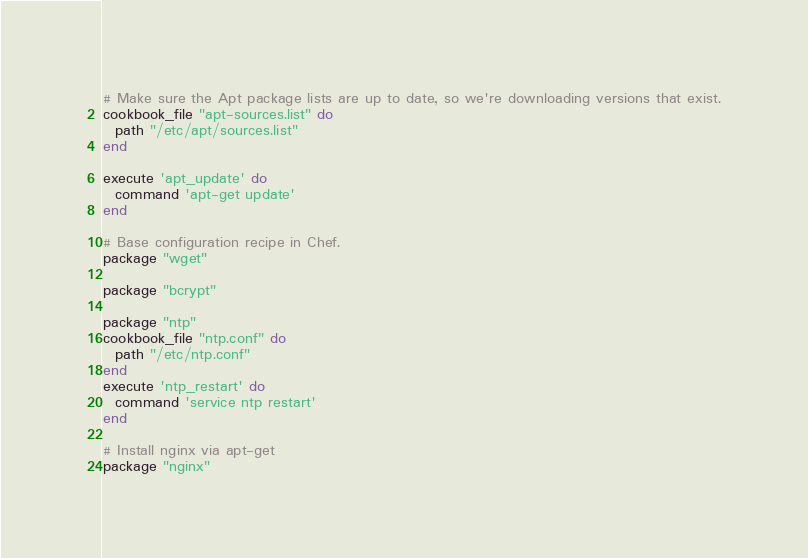<code> <loc_0><loc_0><loc_500><loc_500><_Ruby_># Make sure the Apt package lists are up to date, so we're downloading versions that exist.
cookbook_file "apt-sources.list" do
  path "/etc/apt/sources.list"
end

execute 'apt_update' do
  command 'apt-get update'
end

# Base configuration recipe in Chef.
package "wget"

package "bcrypt"

package "ntp"
cookbook_file "ntp.conf" do
  path "/etc/ntp.conf"
end
execute 'ntp_restart' do
  command 'service ntp restart'
end

# Install nginx via apt-get
package "nginx"</code> 